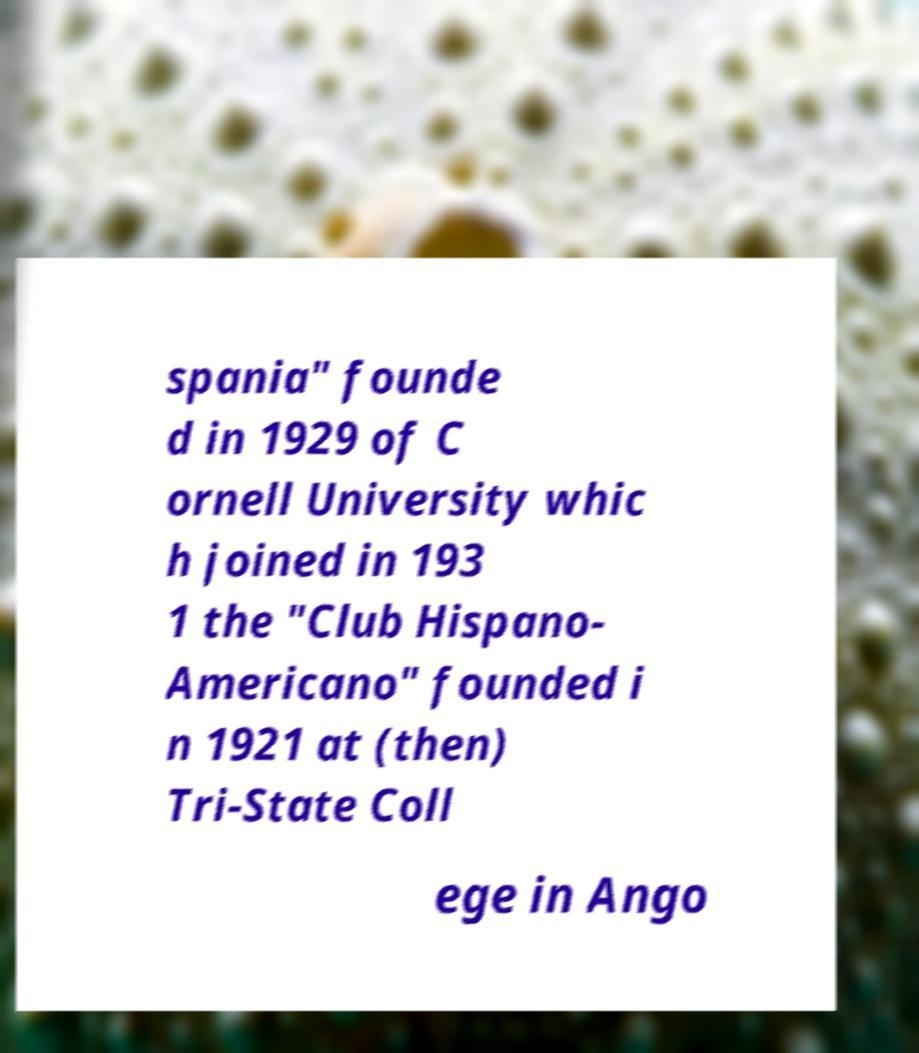There's text embedded in this image that I need extracted. Can you transcribe it verbatim? spania" founde d in 1929 of C ornell University whic h joined in 193 1 the "Club Hispano- Americano" founded i n 1921 at (then) Tri-State Coll ege in Ango 